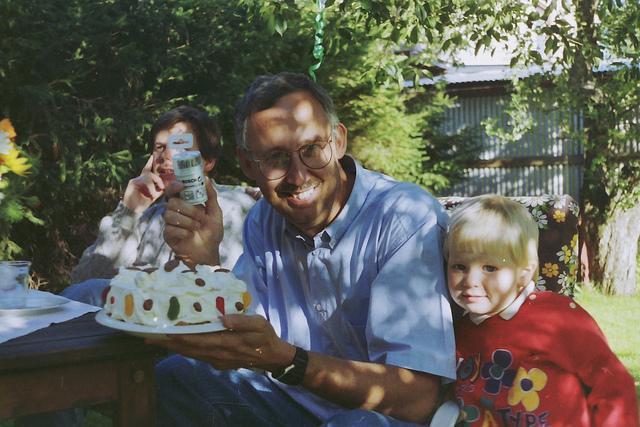What this man doing?
Indicate the correct response by choosing from the four available options to answer the question.
Options: Buying cake, smashing cake, decorating cake, tasting cake. Decorating cake. 